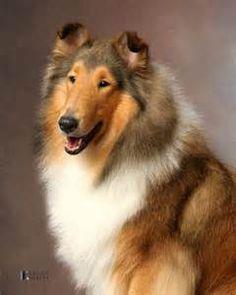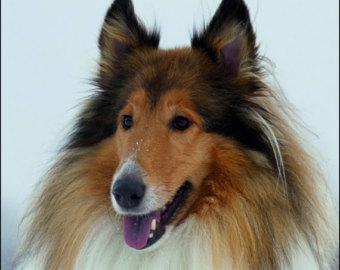The first image is the image on the left, the second image is the image on the right. Examine the images to the left and right. Is the description "The left image features a collie on a mottled, non-white portrait background." accurate? Answer yes or no. Yes. 